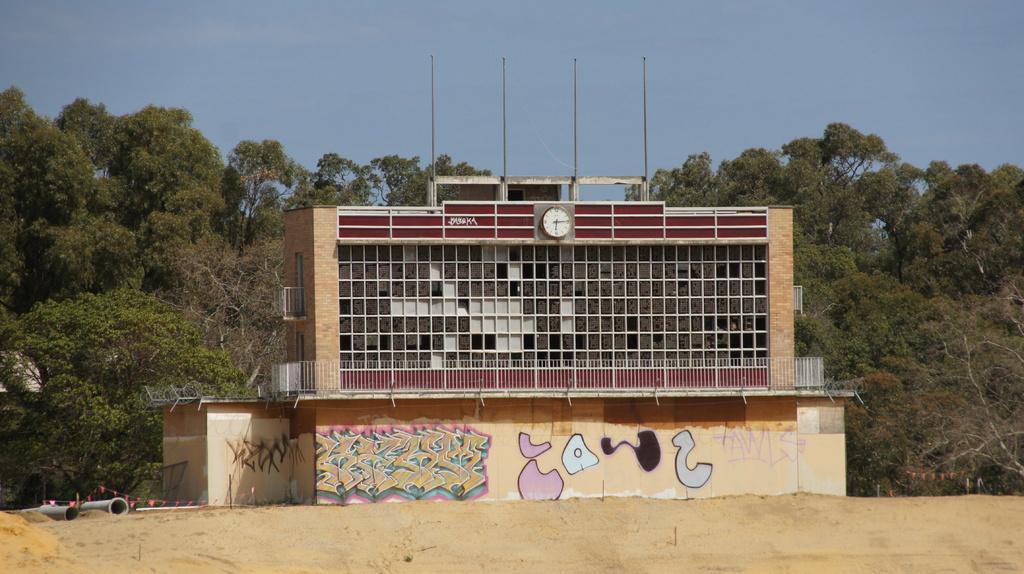Please provide a concise description of this image. In the center of the image there is a building. In the background there are trees. At the top there is sky. At the bottom we can see pipes and sand. 